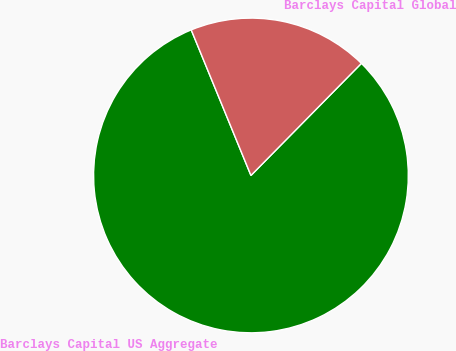Convert chart to OTSL. <chart><loc_0><loc_0><loc_500><loc_500><pie_chart><fcel>Barclays Capital US Aggregate<fcel>Barclays Capital Global<nl><fcel>81.42%<fcel>18.58%<nl></chart> 